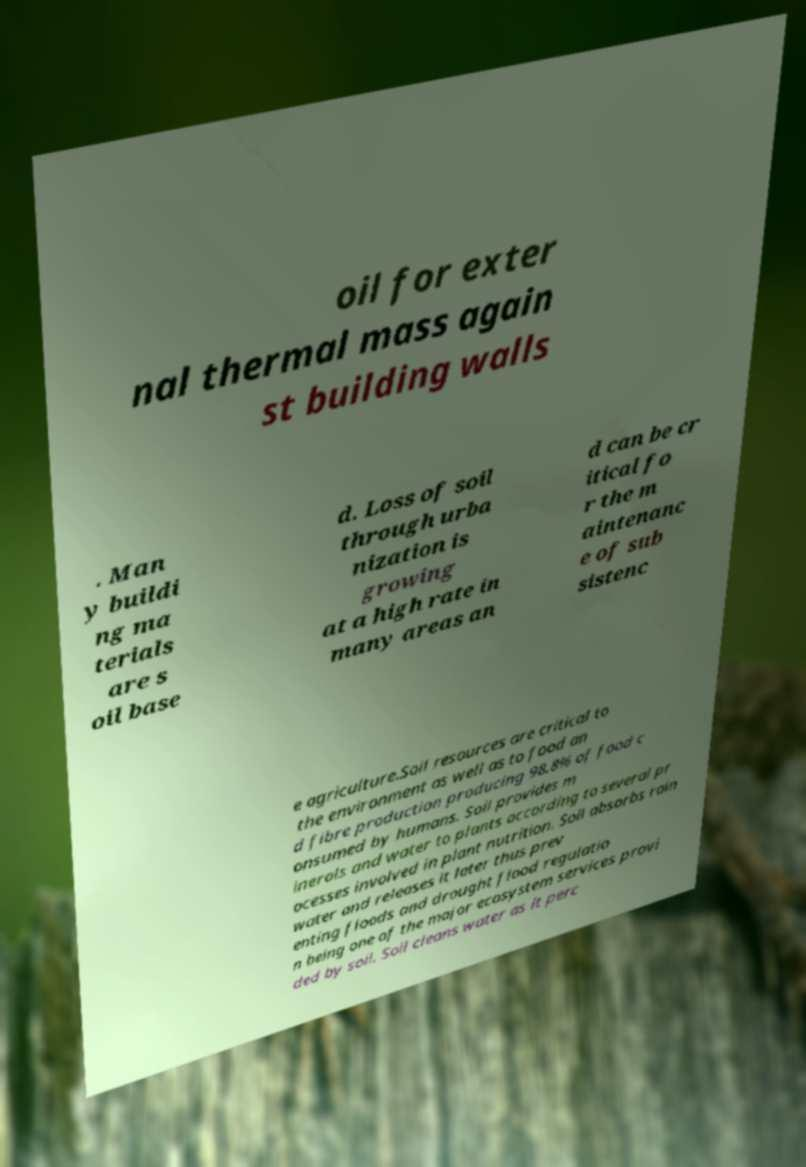Can you read and provide the text displayed in the image?This photo seems to have some interesting text. Can you extract and type it out for me? oil for exter nal thermal mass again st building walls . Man y buildi ng ma terials are s oil base d. Loss of soil through urba nization is growing at a high rate in many areas an d can be cr itical fo r the m aintenanc e of sub sistenc e agriculture.Soil resources are critical to the environment as well as to food an d fibre production producing 98.8% of food c onsumed by humans. Soil provides m inerals and water to plants according to several pr ocesses involved in plant nutrition. Soil absorbs rain water and releases it later thus prev enting floods and drought flood regulatio n being one of the major ecosystem services provi ded by soil. Soil cleans water as it perc 